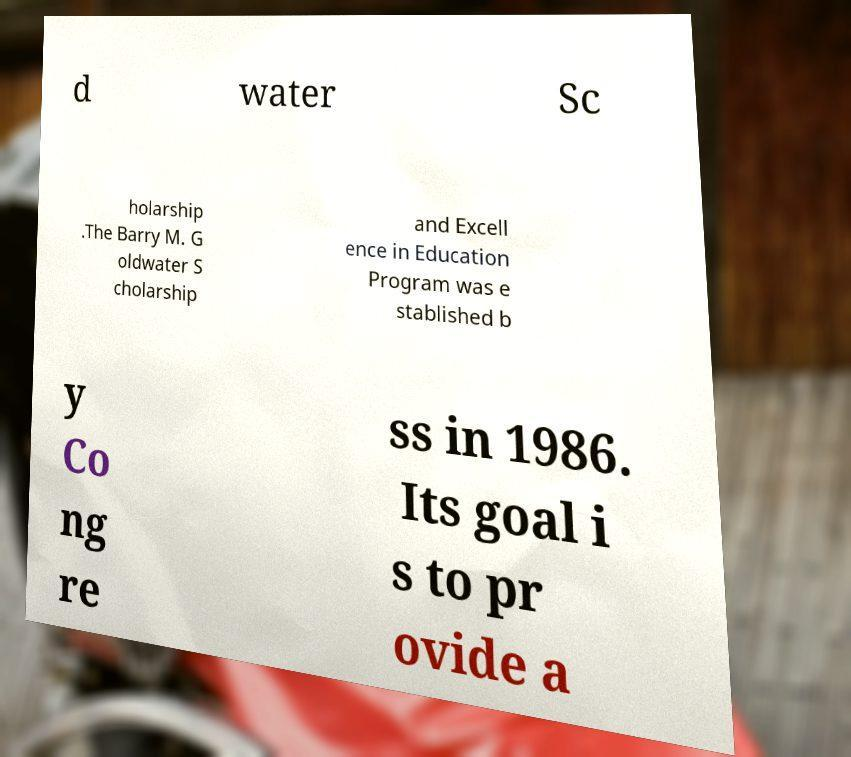Could you extract and type out the text from this image? d water Sc holarship .The Barry M. G oldwater S cholarship and Excell ence in Education Program was e stablished b y Co ng re ss in 1986. Its goal i s to pr ovide a 